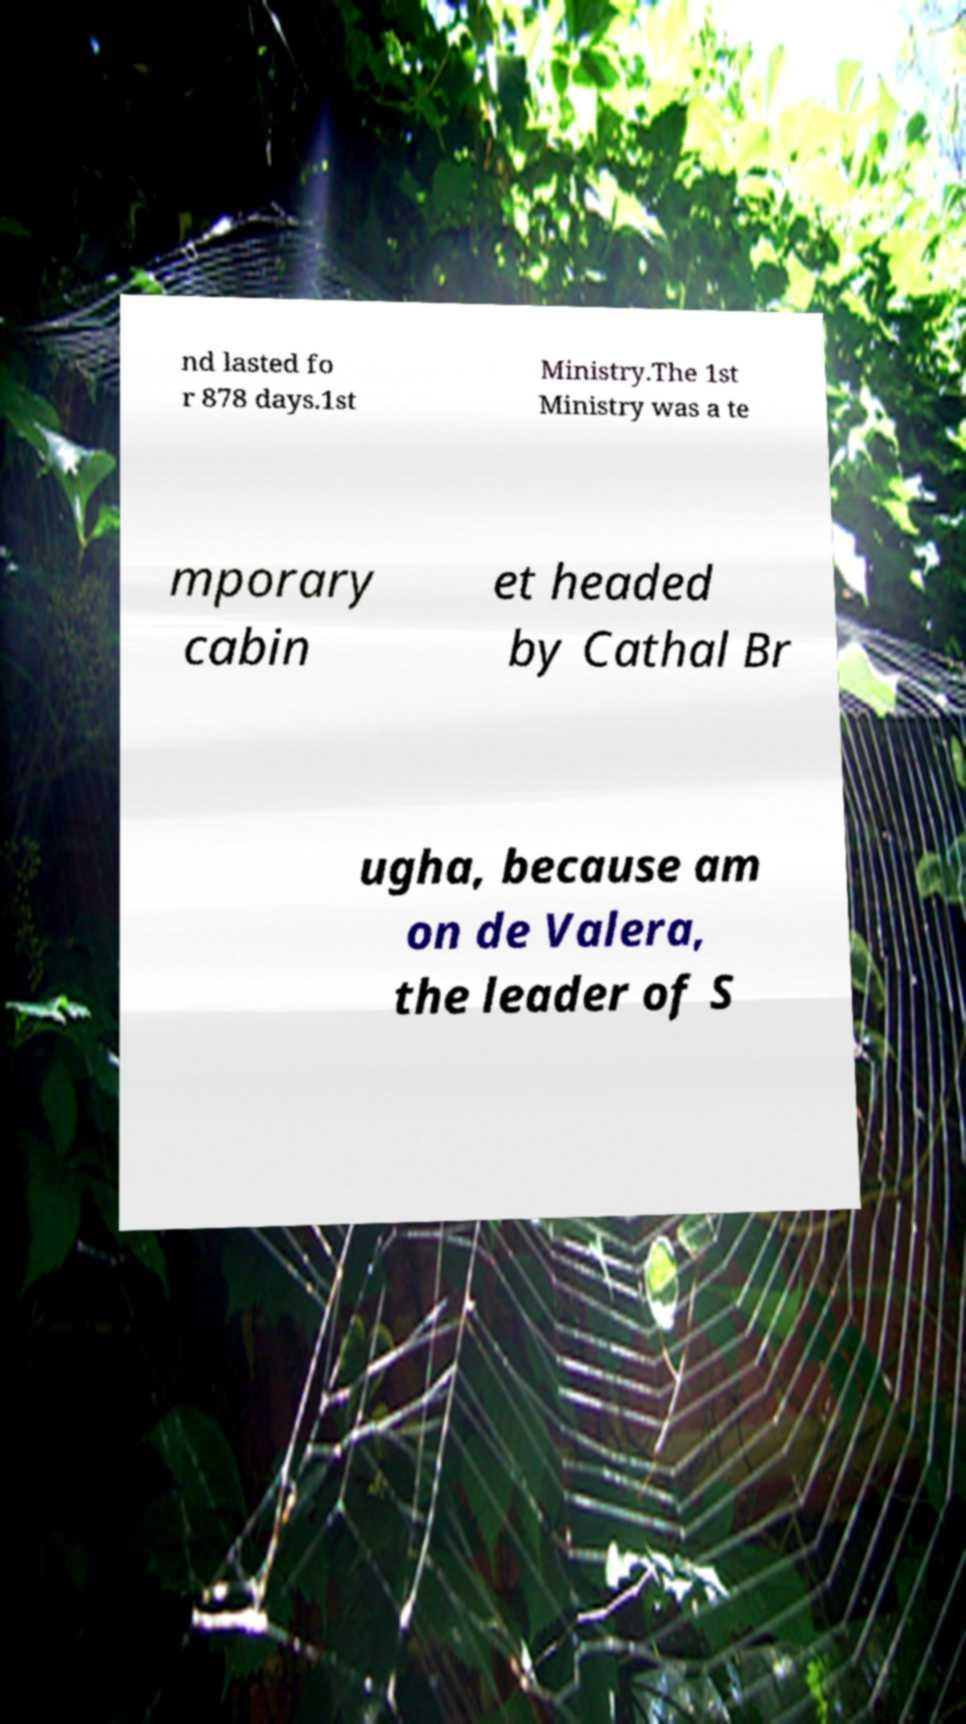Please read and relay the text visible in this image. What does it say? nd lasted fo r 878 days.1st Ministry.The 1st Ministry was a te mporary cabin et headed by Cathal Br ugha, because am on de Valera, the leader of S 